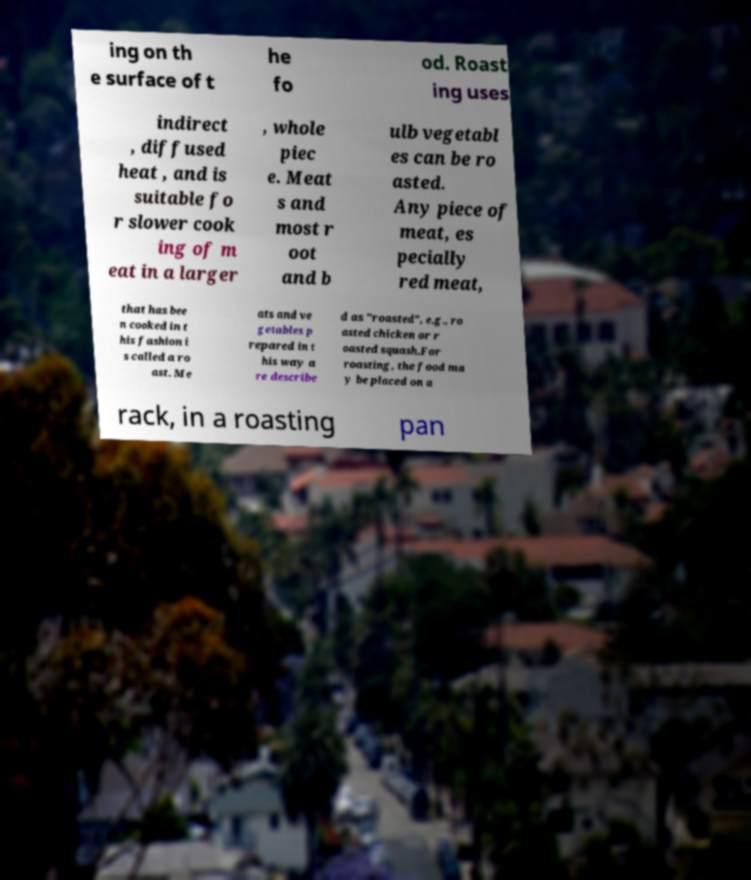Can you read and provide the text displayed in the image?This photo seems to have some interesting text. Can you extract and type it out for me? ing on th e surface of t he fo od. Roast ing uses indirect , diffused heat , and is suitable fo r slower cook ing of m eat in a larger , whole piec e. Meat s and most r oot and b ulb vegetabl es can be ro asted. Any piece of meat, es pecially red meat, that has bee n cooked in t his fashion i s called a ro ast. Me ats and ve getables p repared in t his way a re describe d as "roasted", e.g., ro asted chicken or r oasted squash.For roasting, the food ma y be placed on a rack, in a roasting pan 